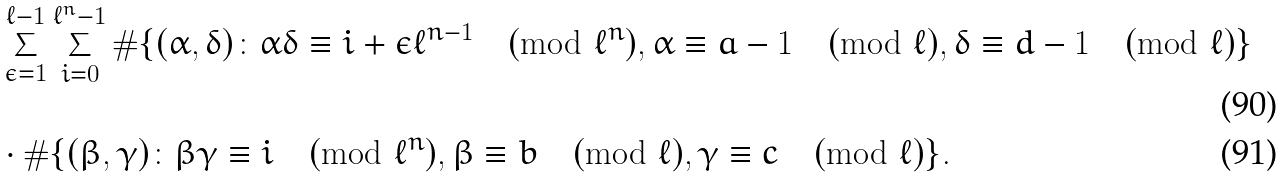<formula> <loc_0><loc_0><loc_500><loc_500>& \sum _ { \epsilon = 1 } ^ { \ell - 1 } \sum _ { i = 0 } ^ { \ell ^ { n } - 1 } \# \{ ( \alpha , \delta ) \colon \alpha \delta \equiv i + \epsilon \ell ^ { n - 1 } \pmod { \ell ^ { n } } , \alpha \equiv a - 1 \pmod { \ell } , \delta \equiv d - 1 \pmod { \ell } \} \\ & \cdot \# \{ ( \beta , \gamma ) \colon \beta \gamma \equiv i \pmod { \ell ^ { n } } , \beta \equiv b \pmod { \ell } , \gamma \equiv c \pmod { \ell } \} .</formula> 